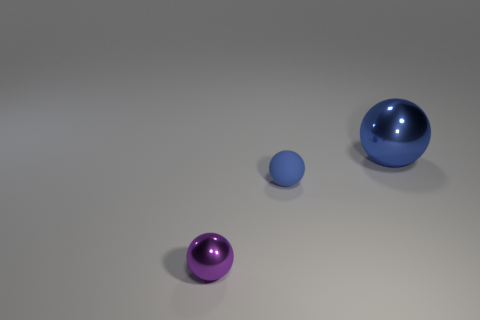Can you guess what material these objects might be made of based on their appearance? Based on their appearance, the objects could be made of a form of plastic or glass, owing to their shiny surfaces and the way they reflect light. Could these objects have any functional purpose, or do they appear to be purely decorative? These objects appear to be purely decorative, as their simple spherical shapes and the setting don't suggest any specific functional purpose. 